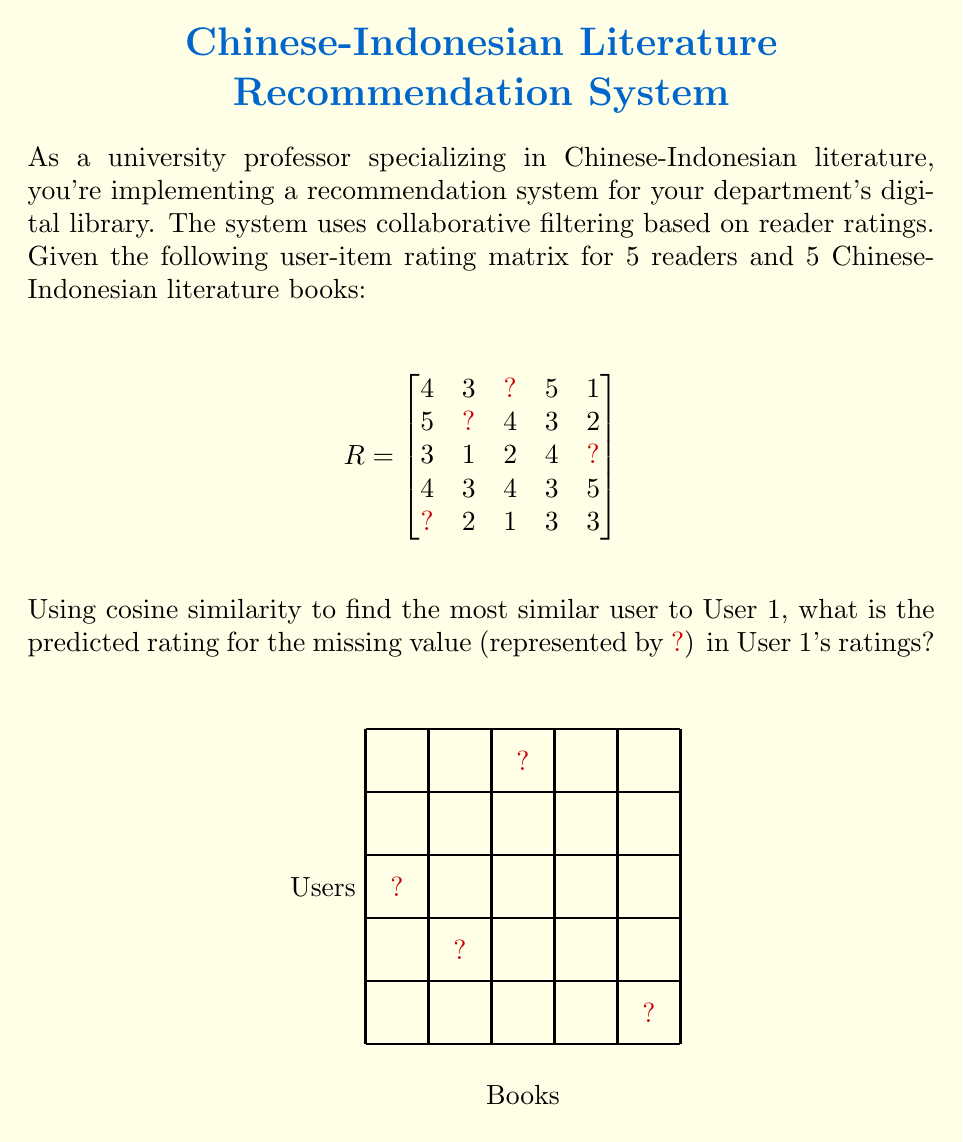Provide a solution to this math problem. To solve this problem, we'll follow these steps:

1) First, we need to calculate the cosine similarity between User 1 and all other users. The cosine similarity formula is:

   $$\text{cosine similarity} = \frac{\sum_{i=1}^n x_i y_i}{\sqrt{\sum_{i=1}^n x_i^2} \sqrt{\sum_{i=1}^n y_i^2}}$$

2) We'll only use the ratings that are available for both users being compared. Let's calculate for User 1 and User 4 (as they have all ratings):

   User 1: [4, 3, 5, 1]
   User 4: [4, 3, 3, 5]

   $$\text{cosine similarity} = \frac{4*4 + 3*3 + 5*3 + 1*5}{\sqrt{4^2 + 3^2 + 5^2 + 1^2} \sqrt{4^2 + 3^2 + 3^2 + 5^2}} = \frac{44}{\sqrt{51} \sqrt{59}} \approx 0.7918$$

3) Calculating for other users:
   User 1 and User 2: ≈ 0.9325
   User 1 and User 3: ≈ 0.9487
   User 1 and User 5: ≈ 0.8944

4) User 3 is the most similar to User 1.

5) To predict the missing rating for User 1, we'll use User 3's rating for the same book (book 3), which is 2.

Therefore, the predicted rating for the missing value in User 1's ratings is 2.
Answer: 2 